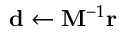<formula> <loc_0><loc_0><loc_500><loc_500>d \leftarrow M ^ { - 1 } r</formula> 